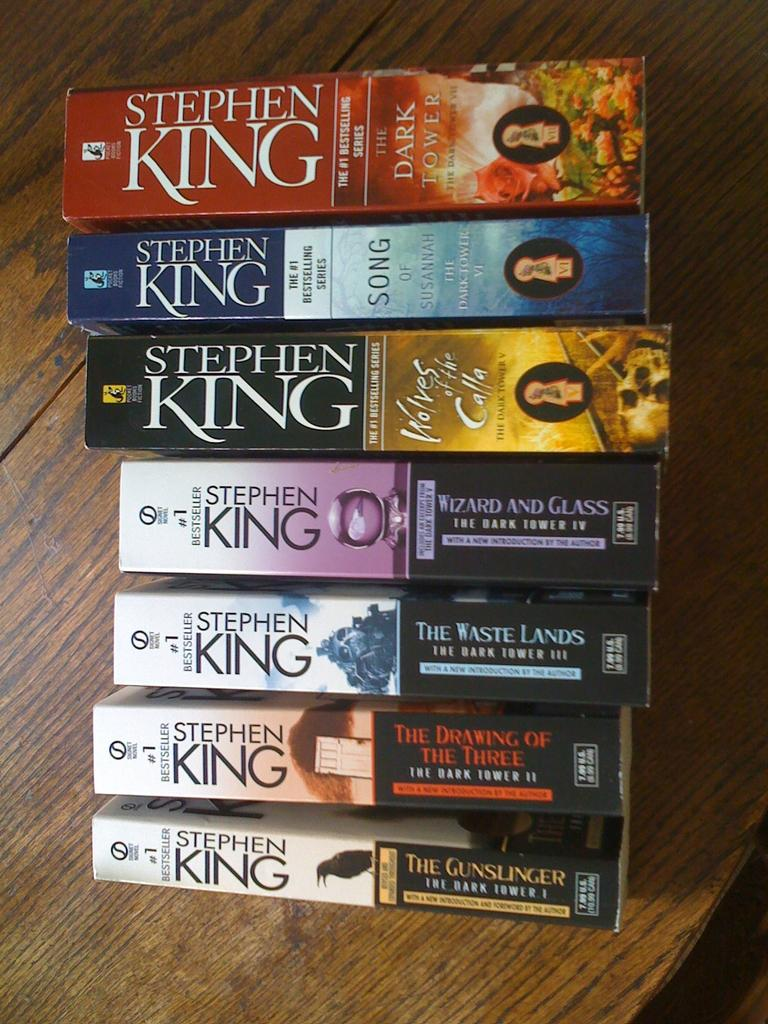<image>
Share a concise interpretation of the image provided. Seven different chapter books that was wrote by Stephen King 